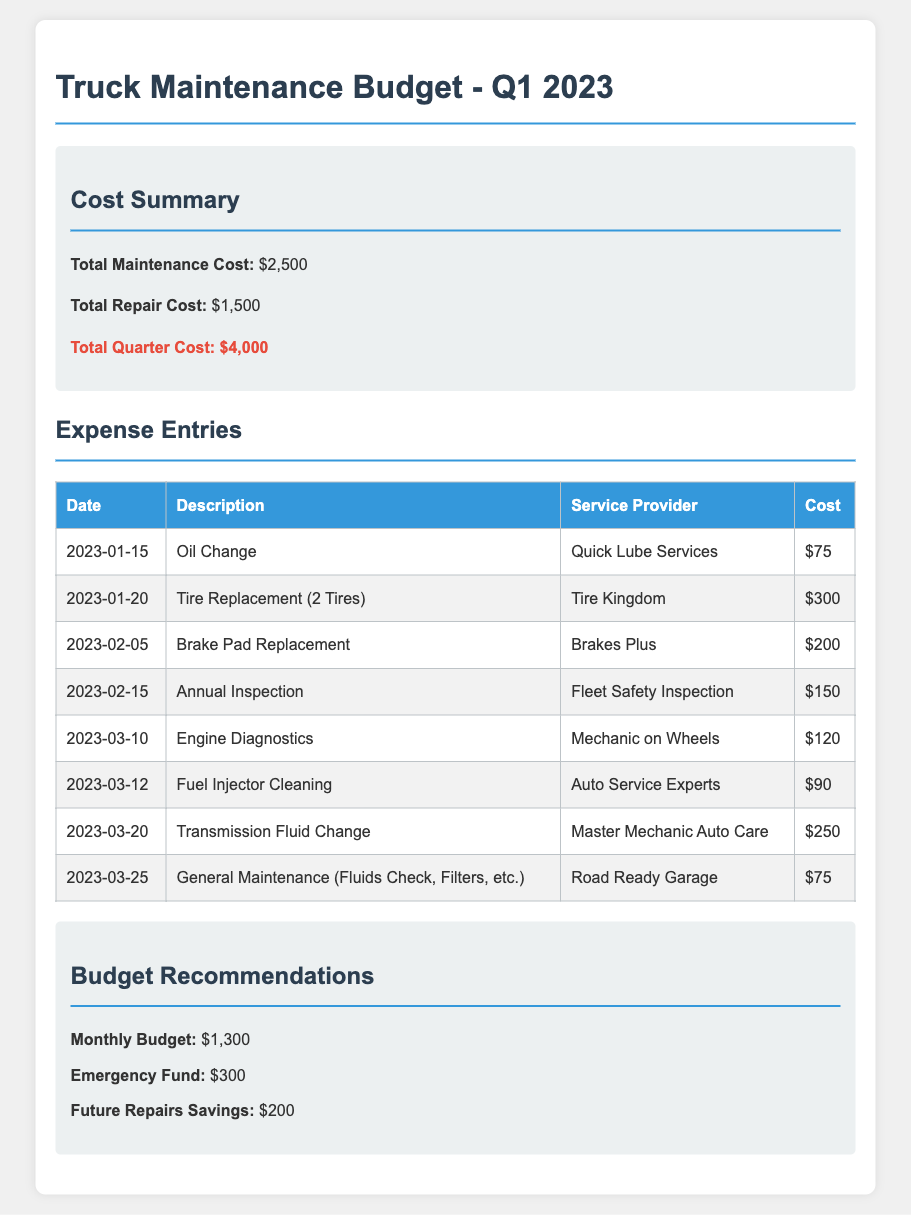what is the total maintenance cost? The total maintenance cost is listed in the document as $2,500.
Answer: $2,500 what is the total quarter cost? The total quarter cost is highlighted in the summary section as $4,000.
Answer: $4,000 when did the oil change occur? The date of the oil change is recorded as 2023-01-15 in the expense entries.
Answer: 2023-01-15 who provided the service for the transmission fluid change? The service for the transmission fluid change was provided by Master Mechanic Auto Care, as noted in the table.
Answer: Master Mechanic Auto Care what is the recommended monthly budget? The recommended monthly budget is specified in the recommendations section as $1,300.
Answer: $1,300 how much did the tire replacement cost? The tire replacement cost for 2 tires is stated in the document as $300.
Answer: $300 how many expenses are listed in the document? There are a total of eight expense entries listed in the document.
Answer: 8 what is the total repair cost? The total repair cost is shown in the summary as $1,500.
Answer: $1,500 what was checked during the general maintenance? The general maintenance included fluids check, filters, etc., according to the expense entry.
Answer: Fluids Check, Filters, etc 